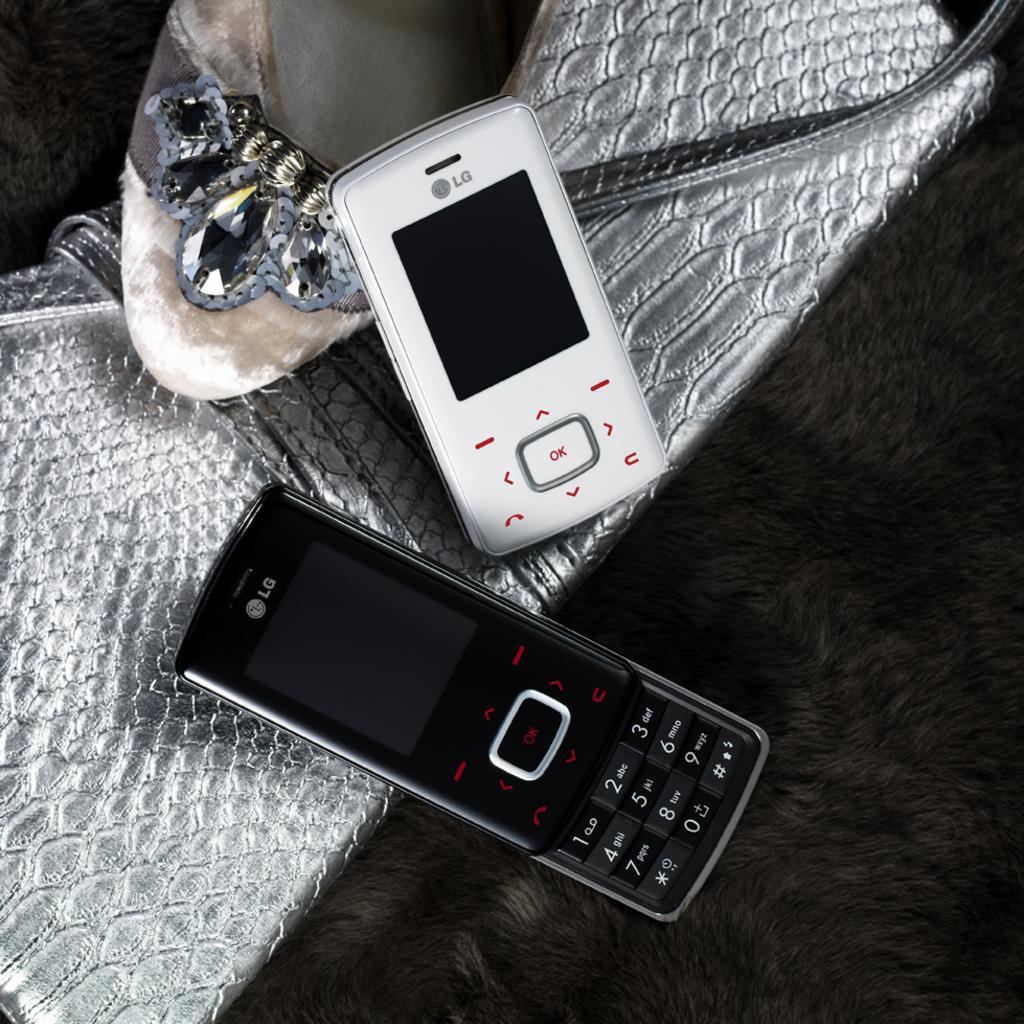Can you describe this image briefly? In the picture I can see two mobile phones, a handbag and a footwear. 